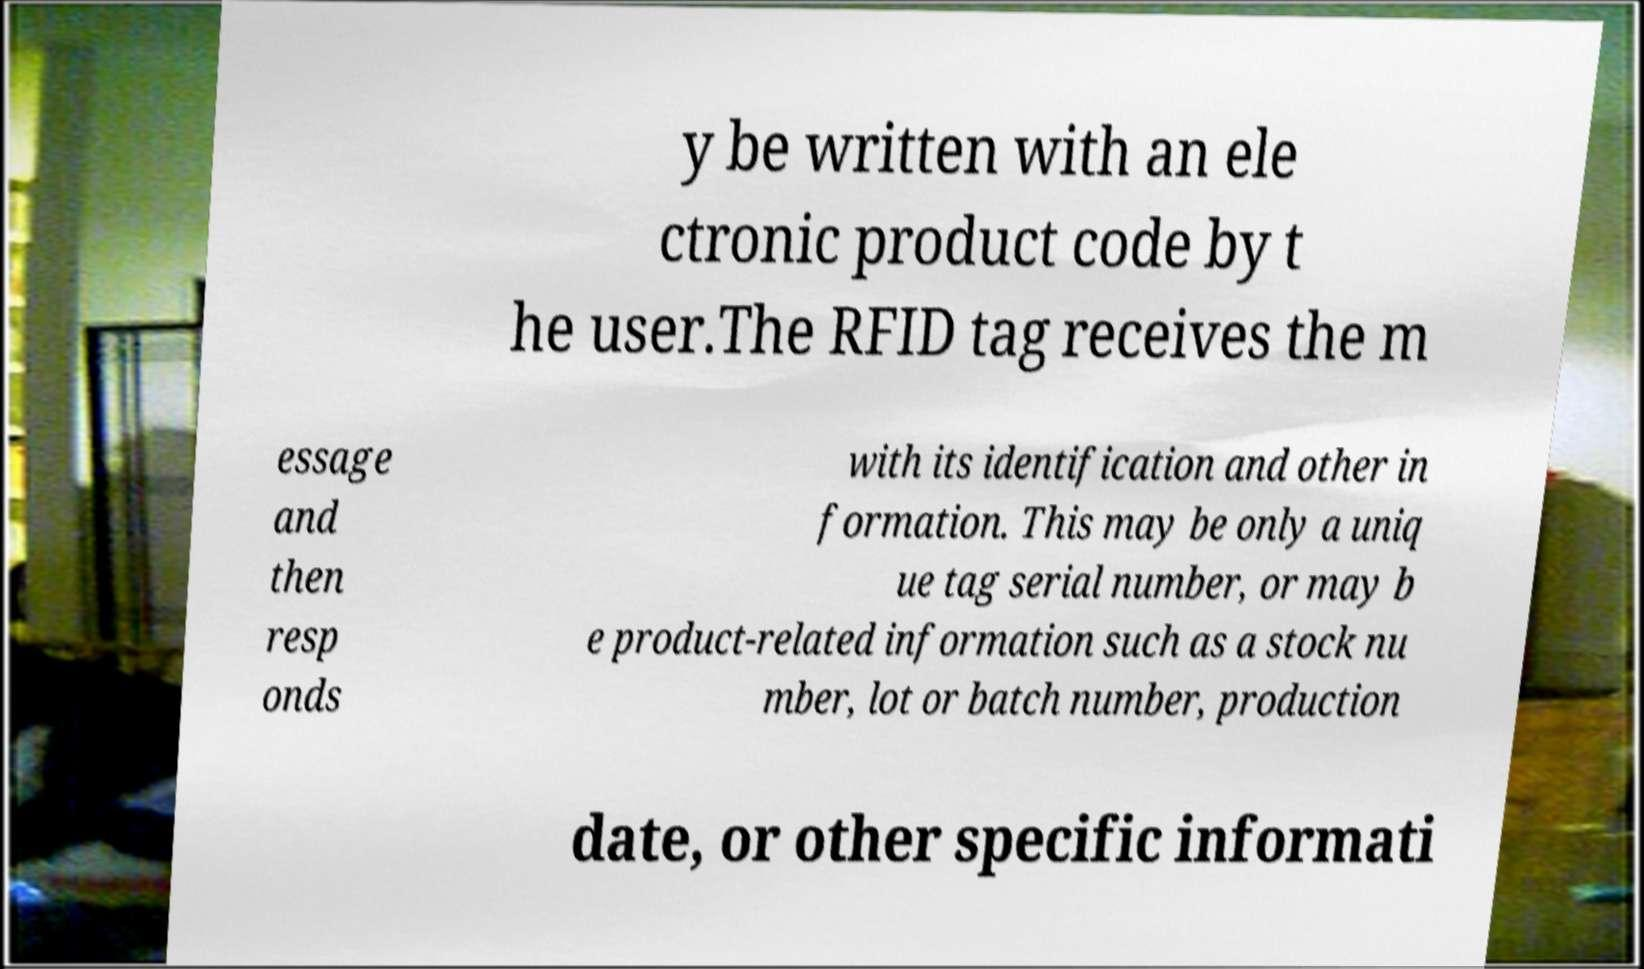Can you accurately transcribe the text from the provided image for me? y be written with an ele ctronic product code by t he user.The RFID tag receives the m essage and then resp onds with its identification and other in formation. This may be only a uniq ue tag serial number, or may b e product-related information such as a stock nu mber, lot or batch number, production date, or other specific informati 